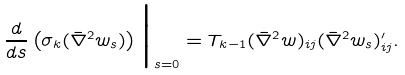Convert formula to latex. <formula><loc_0><loc_0><loc_500><loc_500>\frac { d } { d s } \left ( \sigma _ { k } ( \bar { \nabla } ^ { 2 } w _ { s } ) \right ) \Big | _ { s = 0 } = T _ { k - 1 } ( \bar { \nabla } ^ { 2 } w ) _ { i j } ( \bar { \nabla } ^ { 2 } w _ { s } ) ^ { \prime } _ { i j } .</formula> 